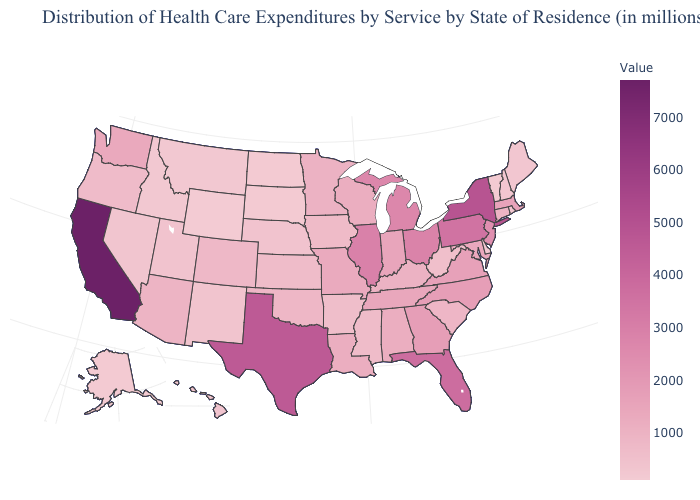Does Rhode Island have a lower value than Florida?
Concise answer only. Yes. Among the states that border New Hampshire , which have the lowest value?
Be succinct. Vermont. Which states have the lowest value in the South?
Quick response, please. Delaware. Does the map have missing data?
Quick response, please. No. Among the states that border Arizona , which have the lowest value?
Quick response, please. Nevada. Which states have the highest value in the USA?
Be succinct. California. 